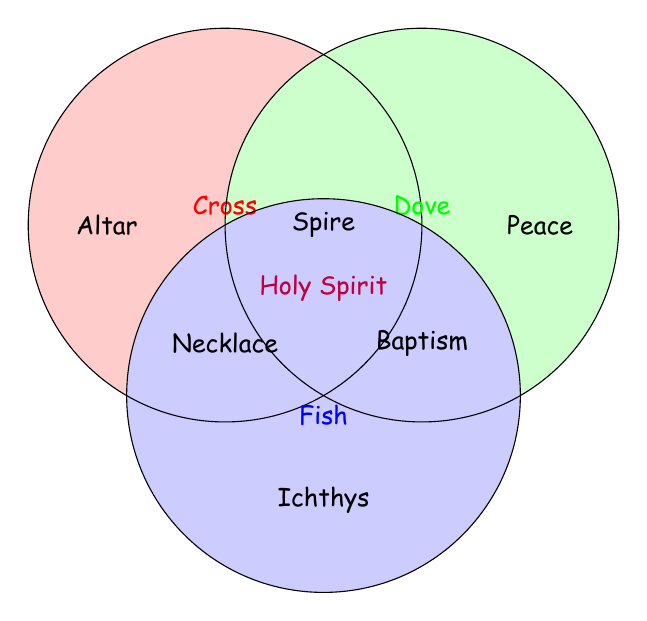What symbols are represented in the figure? There are three symbols represented in the Venn Diagram: Cross, Dove, and Fish. Each symbol has a different color and is labeled in the diagram.
Answer: Cross, Dove, Fish What does the red circle represent? The red circle is labeled as "Cross" in the Venn Diagram, signifying it represents the symbol of the Cross.
Answer: Cross Which symbol is associated with the term "Holy Spirit"? The term "Holy Spirit" is located at the intersection of circles labeled "Cross" and "Dove". This means it is associated with both symbols, Cross and Dove.
Answer: Cross, Dove Where is the term "Necklace" placed in the Venn Diagram? The term "Necklace" is placed within the intersection of Cross and Fish circles in the diagram, meaning it relates to both symbols.
Answer: Cross, Fish How many terms are shared between the Cross and Dove symbols? To determine the number of shared terms, we look at the intersection of the Cross and Dove circles. There is one term: "Holy Spirit".
Answer: 1 Which symbol does "Peace" correspond to? The term "Peace" is placed inside the circle solely labeled "Dove", indicating it is associated only with Dove.
Answer: Dove What does the term "Ichthys" represent in the diagram? The term "Ichthys" is placed inside the circle solely labeled "Fish", showing it is associated only with Fish.
Answer: Fish Find the terms associated with the Cross but not with Dove or Fish. The terms only in the Cross circle and not in other intersections are: "Altar", "Spire".
Answer: Altar, Spire Which term indicates a story related to Dove? The term "Noah's Ark story" isn't explicitly on the diagram, but the closest related term would be understanding that the Dove generally symbolizes "Peace" or is part of "Baptism" imagery. Hence, "Peace".
Answer: Peace What symbols are connected to "Baptism"? The term "Baptism" is placed in the intersection of circles of Dove and Fish, signifying it is connected to both Dove and Fish.
Answer: Dove, Fish 